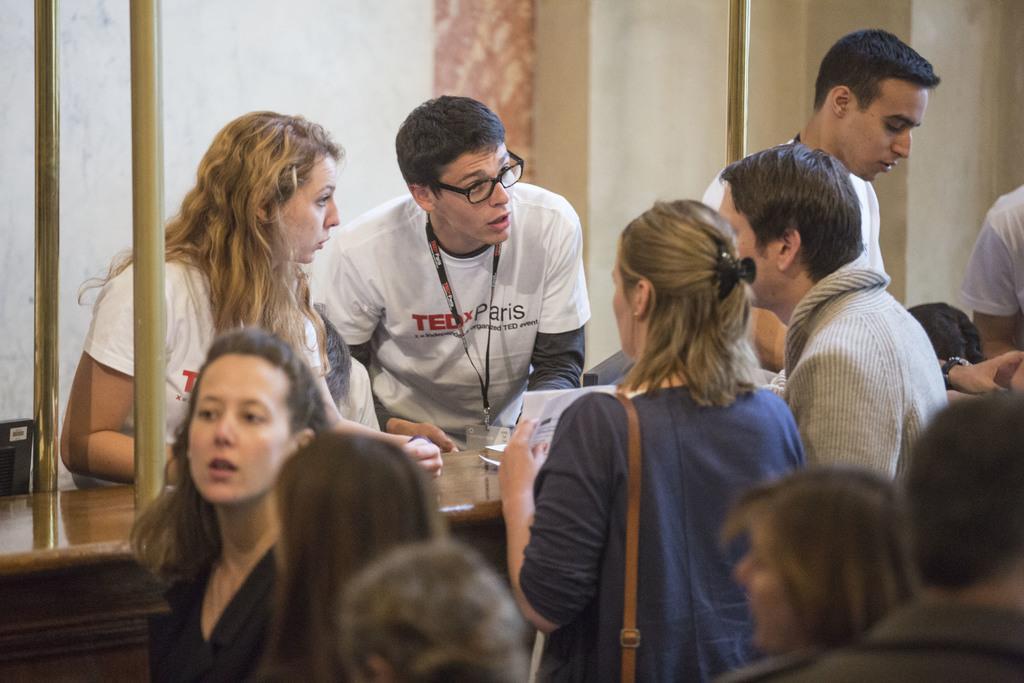How would you summarize this image in a sentence or two? In this image there are group of persons standing, there is a woman wearing a bag and holding an object, there is a wooden desk, there are metal rods towards the top of the image, at the background of the image there is a wall. 